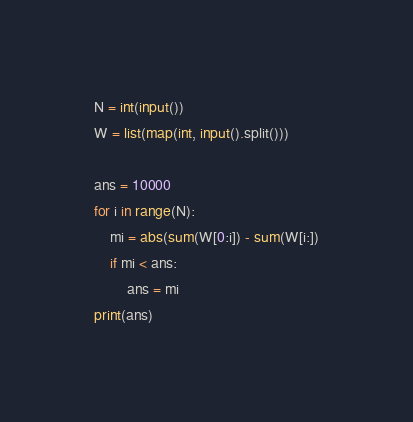Convert code to text. <code><loc_0><loc_0><loc_500><loc_500><_Python_>N = int(input())
W = list(map(int, input().split()))
 
ans = 10000
for i in range(N):
    mi = abs(sum(W[0:i]) - sum(W[i:])
    if mi < ans:
        ans = mi
print(ans)</code> 